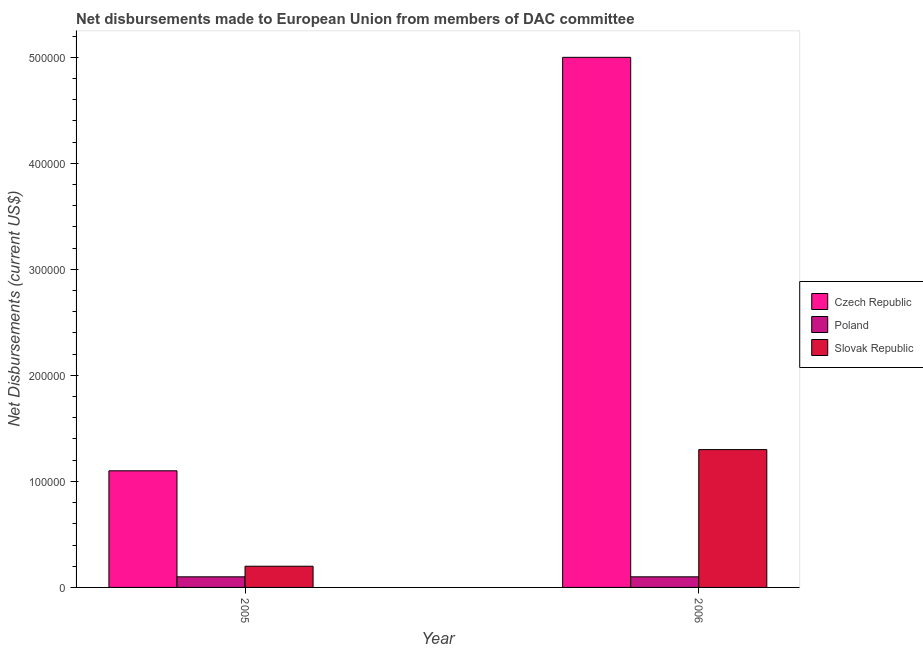How many different coloured bars are there?
Provide a succinct answer. 3. How many groups of bars are there?
Your answer should be very brief. 2. Are the number of bars per tick equal to the number of legend labels?
Ensure brevity in your answer.  Yes. Are the number of bars on each tick of the X-axis equal?
Your response must be concise. Yes. How many bars are there on the 2nd tick from the left?
Offer a terse response. 3. What is the net disbursements made by poland in 2005?
Make the answer very short. 10000. Across all years, what is the maximum net disbursements made by slovak republic?
Offer a very short reply. 1.30e+05. Across all years, what is the minimum net disbursements made by czech republic?
Keep it short and to the point. 1.10e+05. In which year was the net disbursements made by czech republic minimum?
Make the answer very short. 2005. What is the total net disbursements made by slovak republic in the graph?
Offer a very short reply. 1.50e+05. What is the difference between the net disbursements made by slovak republic in 2006 and the net disbursements made by poland in 2005?
Give a very brief answer. 1.10e+05. What is the average net disbursements made by slovak republic per year?
Offer a very short reply. 7.50e+04. In the year 2006, what is the difference between the net disbursements made by poland and net disbursements made by slovak republic?
Offer a very short reply. 0. In how many years, is the net disbursements made by slovak republic greater than 320000 US$?
Offer a terse response. 0. What is the ratio of the net disbursements made by czech republic in 2005 to that in 2006?
Make the answer very short. 0.22. What does the 3rd bar from the right in 2006 represents?
Your answer should be very brief. Czech Republic. Is it the case that in every year, the sum of the net disbursements made by czech republic and net disbursements made by poland is greater than the net disbursements made by slovak republic?
Give a very brief answer. Yes. How many bars are there?
Your answer should be very brief. 6. Are all the bars in the graph horizontal?
Give a very brief answer. No. What is the difference between two consecutive major ticks on the Y-axis?
Make the answer very short. 1.00e+05. Are the values on the major ticks of Y-axis written in scientific E-notation?
Offer a very short reply. No. Does the graph contain any zero values?
Your response must be concise. No. How many legend labels are there?
Give a very brief answer. 3. What is the title of the graph?
Your answer should be very brief. Net disbursements made to European Union from members of DAC committee. Does "Solid fuel" appear as one of the legend labels in the graph?
Offer a terse response. No. What is the label or title of the X-axis?
Provide a succinct answer. Year. What is the label or title of the Y-axis?
Provide a short and direct response. Net Disbursements (current US$). What is the Net Disbursements (current US$) of Czech Republic in 2005?
Your answer should be compact. 1.10e+05. What is the Net Disbursements (current US$) of Poland in 2005?
Your response must be concise. 10000. What is the Net Disbursements (current US$) of Czech Republic in 2006?
Give a very brief answer. 5.00e+05. What is the Net Disbursements (current US$) in Slovak Republic in 2006?
Your answer should be compact. 1.30e+05. Across all years, what is the maximum Net Disbursements (current US$) of Czech Republic?
Offer a very short reply. 5.00e+05. Across all years, what is the maximum Net Disbursements (current US$) in Poland?
Offer a terse response. 10000. Across all years, what is the minimum Net Disbursements (current US$) of Czech Republic?
Offer a very short reply. 1.10e+05. Across all years, what is the minimum Net Disbursements (current US$) in Poland?
Give a very brief answer. 10000. What is the total Net Disbursements (current US$) of Czech Republic in the graph?
Your response must be concise. 6.10e+05. What is the total Net Disbursements (current US$) of Slovak Republic in the graph?
Provide a short and direct response. 1.50e+05. What is the difference between the Net Disbursements (current US$) of Czech Republic in 2005 and that in 2006?
Offer a very short reply. -3.90e+05. What is the difference between the Net Disbursements (current US$) in Poland in 2005 and that in 2006?
Your answer should be compact. 0. What is the difference between the Net Disbursements (current US$) in Slovak Republic in 2005 and that in 2006?
Keep it short and to the point. -1.10e+05. What is the difference between the Net Disbursements (current US$) in Czech Republic in 2005 and the Net Disbursements (current US$) in Poland in 2006?
Offer a very short reply. 1.00e+05. What is the difference between the Net Disbursements (current US$) of Czech Republic in 2005 and the Net Disbursements (current US$) of Slovak Republic in 2006?
Provide a succinct answer. -2.00e+04. What is the difference between the Net Disbursements (current US$) of Poland in 2005 and the Net Disbursements (current US$) of Slovak Republic in 2006?
Your answer should be compact. -1.20e+05. What is the average Net Disbursements (current US$) in Czech Republic per year?
Your response must be concise. 3.05e+05. What is the average Net Disbursements (current US$) in Poland per year?
Your response must be concise. 10000. What is the average Net Disbursements (current US$) in Slovak Republic per year?
Offer a very short reply. 7.50e+04. In the year 2005, what is the difference between the Net Disbursements (current US$) of Poland and Net Disbursements (current US$) of Slovak Republic?
Ensure brevity in your answer.  -10000. What is the ratio of the Net Disbursements (current US$) in Czech Republic in 2005 to that in 2006?
Your answer should be compact. 0.22. What is the ratio of the Net Disbursements (current US$) of Poland in 2005 to that in 2006?
Your answer should be very brief. 1. What is the ratio of the Net Disbursements (current US$) in Slovak Republic in 2005 to that in 2006?
Your answer should be very brief. 0.15. What is the difference between the highest and the second highest Net Disbursements (current US$) in Czech Republic?
Your answer should be very brief. 3.90e+05. What is the difference between the highest and the second highest Net Disbursements (current US$) of Poland?
Provide a short and direct response. 0. What is the difference between the highest and the second highest Net Disbursements (current US$) of Slovak Republic?
Provide a succinct answer. 1.10e+05. What is the difference between the highest and the lowest Net Disbursements (current US$) in Czech Republic?
Your response must be concise. 3.90e+05. What is the difference between the highest and the lowest Net Disbursements (current US$) of Poland?
Make the answer very short. 0. 